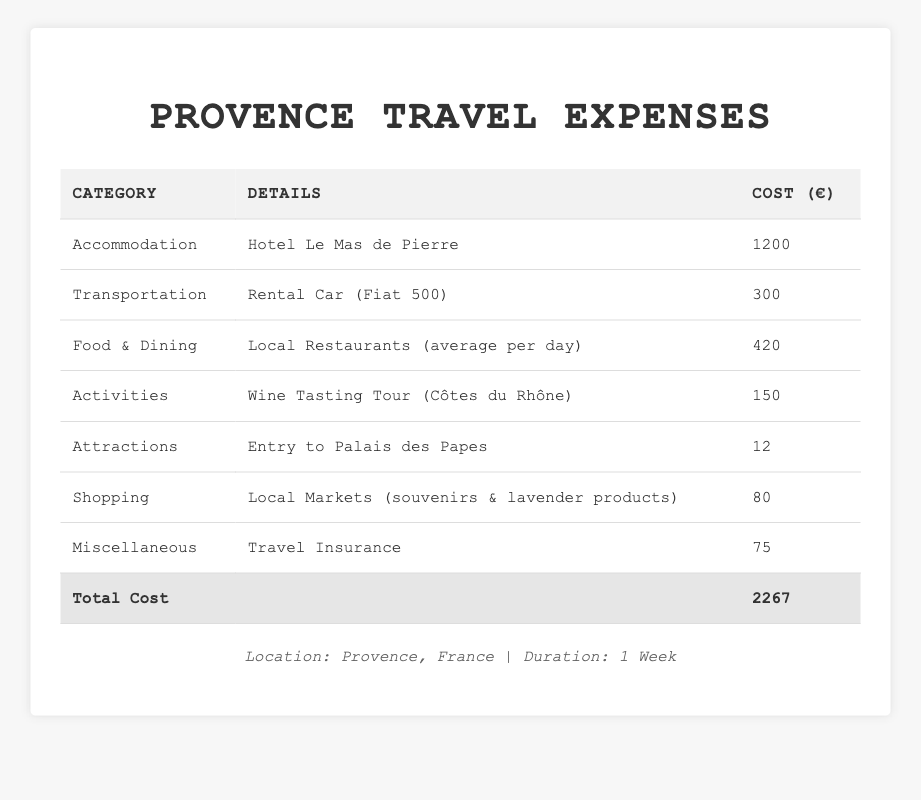What is the cost of accommodation in Provence? The table lists the category "Accommodation," where the details state "Hotel Le Mas de Pierre," and the cost is specified as 1200 euros.
Answer: 1200 euros How much did the wine tasting tour cost? In the table under the "Activities" category, it states that the "Wine Tasting Tour (Côtes du Rhône)" costs 150 euros.
Answer: 150 euros What was the total cost for food and dining during the week? The table indicates that the category "Food & Dining" has a "TotalCost" of 420 euros.
Answer: 420 euros Is the cost of transportation more than the cost of shopping? Transportation costs 300 euros and shopping costs 80 euros. Since 300 > 80, the statement is true.
Answer: Yes What is the total expenditure for the week in Provence? The "Total Cost" row in the table shows a value of 2267 euros, which is the total expenditure for the week.
Answer: 2267 euros If you add the costs for accommodation and transportation, what do you get? Accommodation costs 1200 euros and transportation costs 300 euros. Adding these together: 1200 + 300 = 1500 euros.
Answer: 1500 euros What was the average daily cost for food and dining over the week? The total cost for food and dining is 420 euros for 7 days. Dividing 420 by 7 gives us an average daily cost of 60 euros.
Answer: 60 euros How much was spent on miscellaneous expenses compared to attractions? The miscellaneous expenses amounted to 75 euros and the cost for attractions was 12 euros. The difference is 75 - 12 = 63 euros. So, 63 euros more was spent on miscellaneous expenses.
Answer: 63 euros What percentage of the total cost was spent on accommodation? The accommodation cost is 1200 euros out of the total cost of 2267 euros. Calculating the percentage gives us (1200/2267) * 100 ≈ 52.9%.
Answer: 52.9% If someone wanted to allocate the total cost evenly over 7 days, how much would they spend per day? The total cost is 2267 euros. Dividing this by 7 days gives us approximately 323.86 euros per day.
Answer: 323.86 euros 